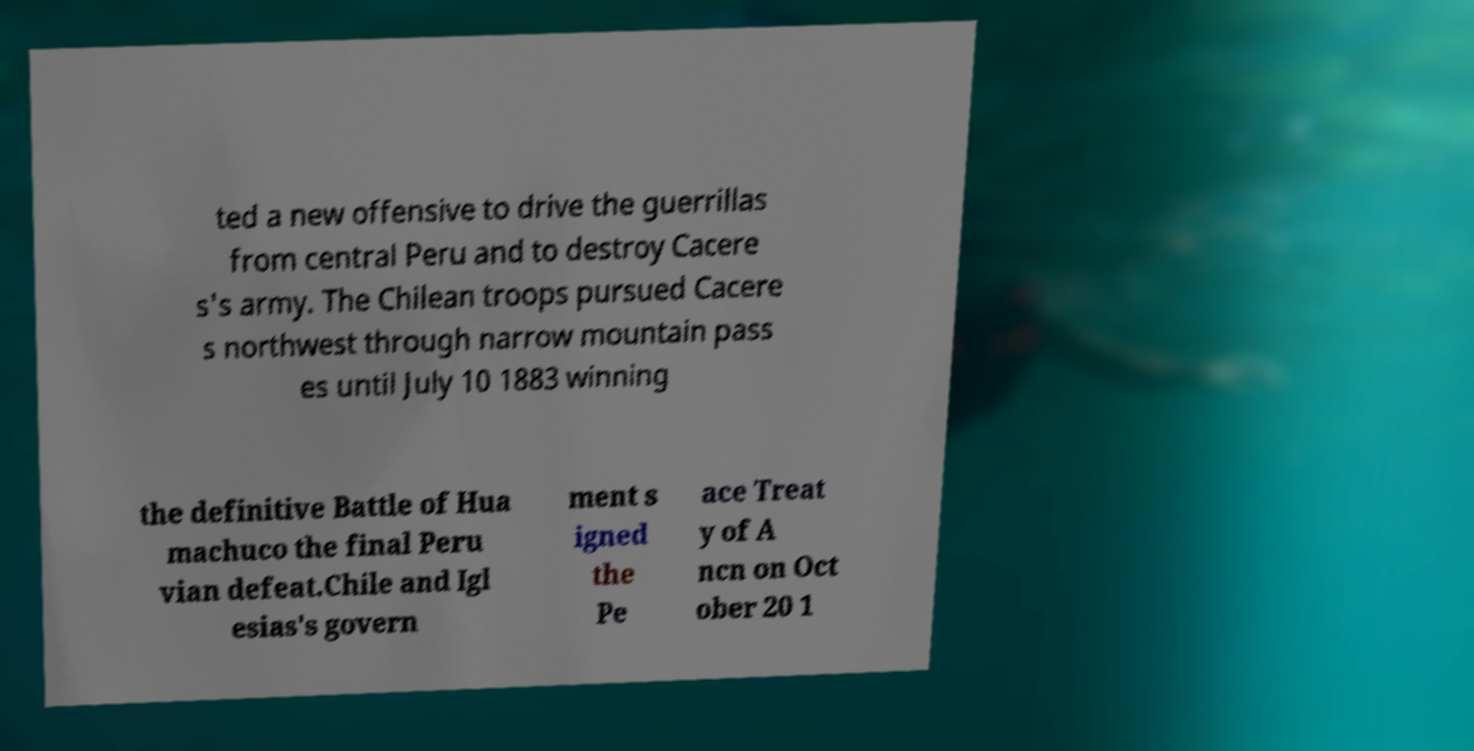What messages or text are displayed in this image? I need them in a readable, typed format. ted a new offensive to drive the guerrillas from central Peru and to destroy Cacere s's army. The Chilean troops pursued Cacere s northwest through narrow mountain pass es until July 10 1883 winning the definitive Battle of Hua machuco the final Peru vian defeat.Chile and Igl esias's govern ment s igned the Pe ace Treat y of A ncn on Oct ober 20 1 